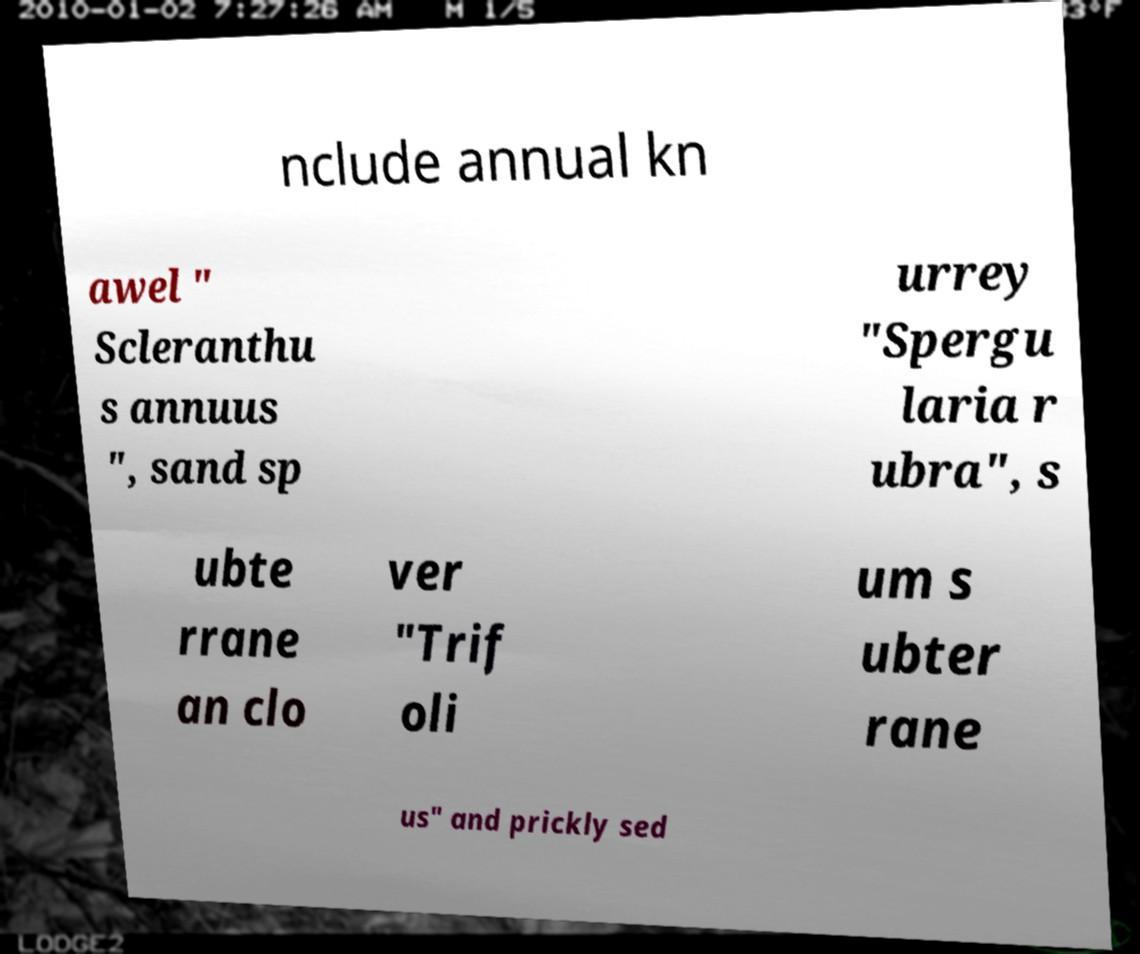Please identify and transcribe the text found in this image. nclude annual kn awel " Scleranthu s annuus ", sand sp urrey "Spergu laria r ubra", s ubte rrane an clo ver "Trif oli um s ubter rane us" and prickly sed 